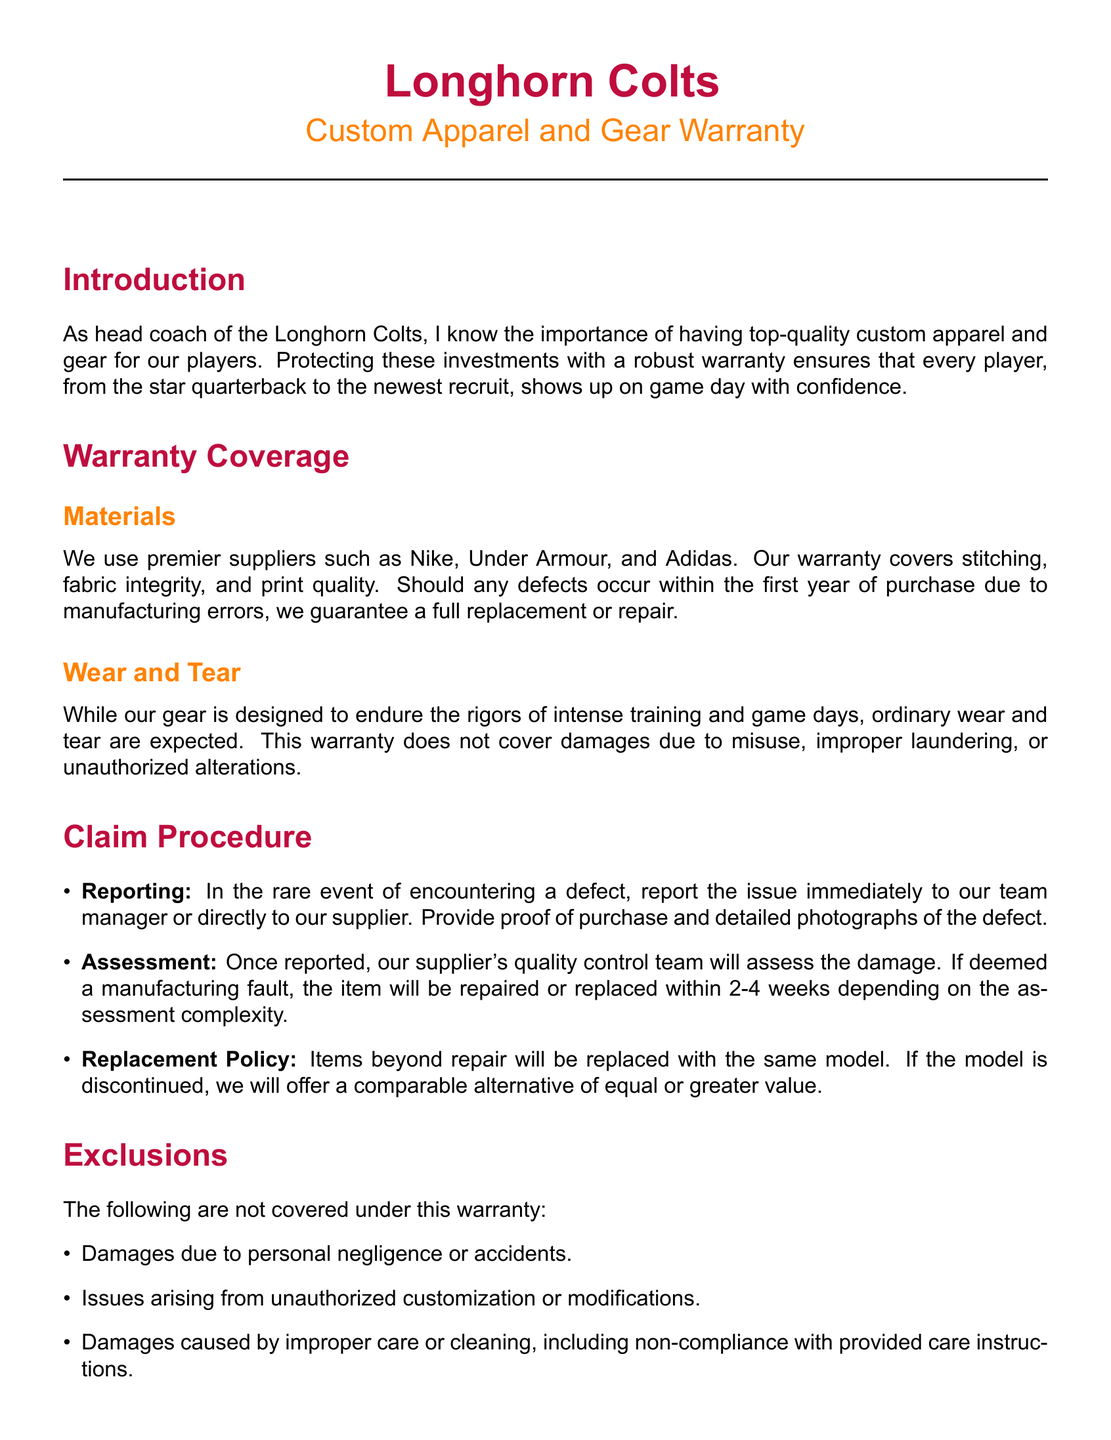what is the duration of the warranty coverage? The warranty covers manufacturing defects for one year from the date of purchase.
Answer: one year who are the premier suppliers mentioned in the warranty? The warranty specifically lists Nike, Under Armour, and Adidas as suppliers.
Answer: Nike, Under Armour, and Adidas what is the assessment time frame for warranty claims? The document states that items will be assessed and repaired or replaced within 2-4 weeks.
Answer: 2-4 weeks what types of damages are excluded from the warranty? The exclusions include damages due to personal negligence, unauthorized modifications, and improper care.
Answer: personal negligence, unauthorized modifications, improper care what cleaning method is recommended for the apparel? The document advises to wash items in cold water with similar colors.
Answer: cold water what should be provided when reporting a warranty issue? The document specifies that proof of purchase and detailed photographs of the defect should be provided.
Answer: proof of purchase and detailed photographs what is the process once a defect is reported? The warranty process includes reporting the issue, assessment by the supplier, and replacement or repair.
Answer: reporting, assessment, replacement or repair how should the apparel be stored to prevent damage? The item should be stored in a cool, dry place away from direct sunlight.
Answer: cool, dry place away from direct sunlight what is the contact email for warranty inquiries? The warranty document provides a specific support email for inquiries.
Answer: support@longhorncoltsgear.com 